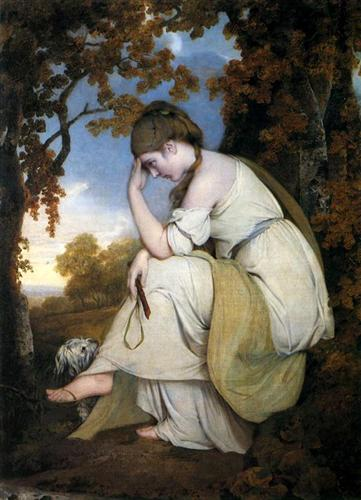Describe the setting of this painting in detail. The setting of this painting is a tranquil woodland, captured during the soft, glowing moments of a sunset. The woman is situated on a rock, surrounded by a variety of trees that create a natural frame around her. The leaves are beginning to turn, hinting at the arrival of autumn. The sky in the background transforms from a soft blue to a warm, golden hue as the sun sets, casting a gentle light over the landscape. In the distance, hints of a rolling meadow are visible, further enhancing the painting's serene and reflective mood. 